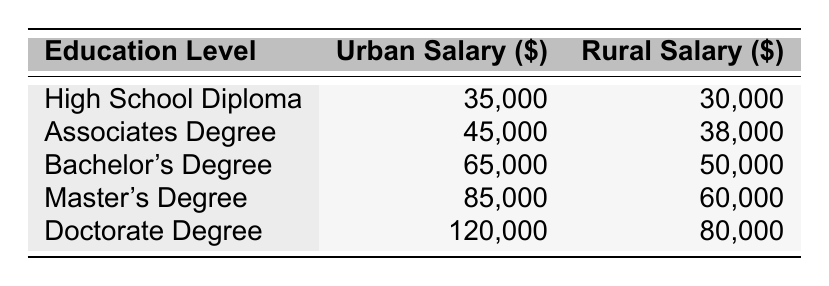What is the urban salary for someone with a master's degree? According to the table, the salary listed for individuals with a master's degree in urban areas is 85,000.
Answer: 85,000 What is the rural salary for someone with a bachelor's degree? Referring to the table, the rural salary for a bachelor's degree holder is stated as 50,000.
Answer: 50,000 What is the difference in salary between a doctorate degree holder in urban areas and a high school diploma holder in rural areas? The urban salary for a doctorate degree holder is 120,000, while the rural salary for a high school diploma holder is 30,000. The difference is 120,000 - 30,000 = 90,000.
Answer: 90,000 Does an associate degree lead to a higher urban salary than a high school diploma? The urban salary for an associate degree is 45,000, while for a high school diploma it is 35,000. Since 45,000 is greater than 35,000, the answer is yes.
Answer: Yes Which education level has the largest gap between urban and rural salaries? By analyzing the differences for each education level, we find: Doctorate (120,000 - 80,000 = 40,000), Master's (85,000 - 60,000 = 25,000), Bachelor's (65,000 - 50,000 = 15,000), Associates (45,000 - 38,000 = 7,000), and High School (35,000 - 30,000 = 5,000). The largest gap of 40,000 belongs to the doctorate degree.
Answer: Doctorate Degree 